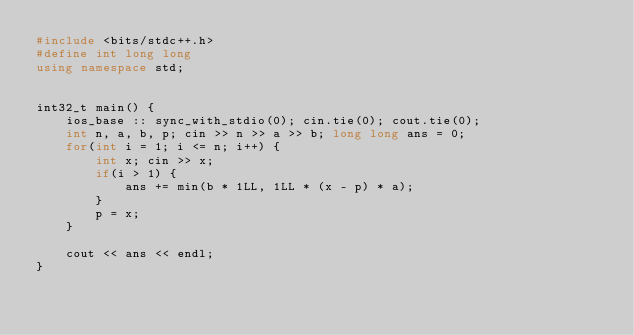Convert code to text. <code><loc_0><loc_0><loc_500><loc_500><_C++_>#include <bits/stdc++.h>
#define int long long
using namespace std;


int32_t main() {
	ios_base :: sync_with_stdio(0); cin.tie(0); cout.tie(0);
	int n, a, b, p; cin >> n >> a >> b; long long ans = 0;
	for(int i = 1; i <= n; i++) {
		int x; cin >> x;
		if(i > 1) {
			ans += min(b * 1LL, 1LL * (x - p) * a);
		}
		p = x;
	}

	cout << ans << endl;
}</code> 